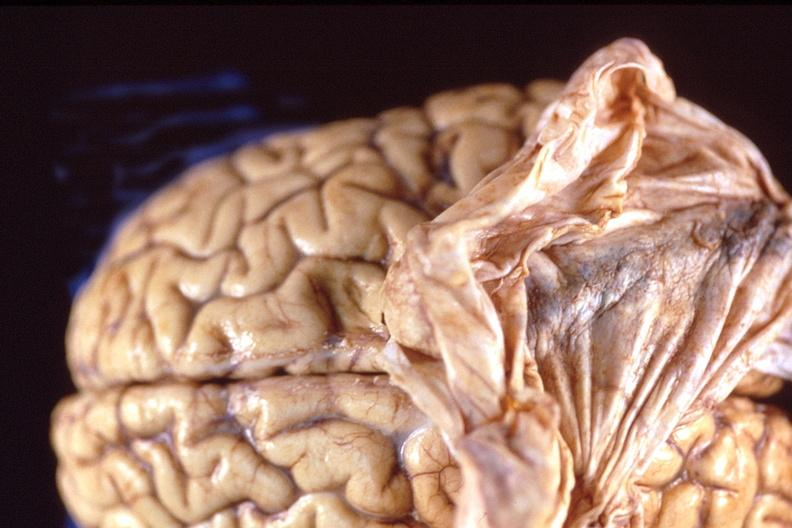s infant body present?
Answer the question using a single word or phrase. No 